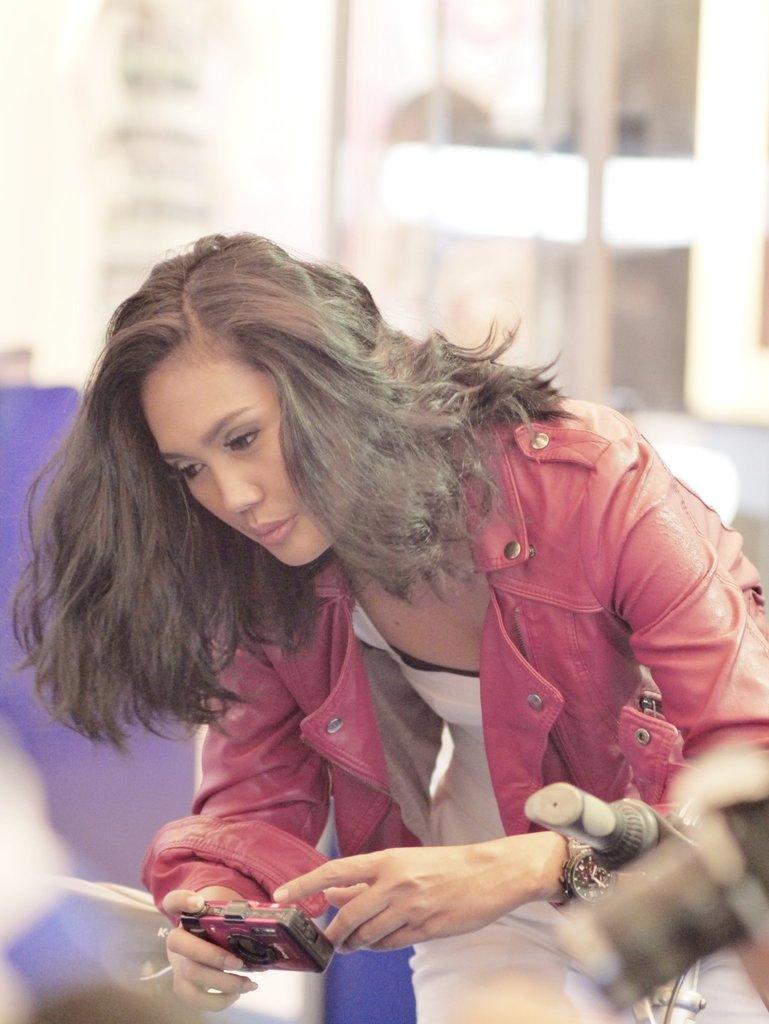Who is the main subject in the image? There is a woman in the image. Where is the woman located in the image? The woman is in the center of the image. What is the woman holding in the image? The woman is holding a camera. What type of eggs can be seen in the garden in the image? There is no garden or eggs present in the image; it features a woman holding a camera. 